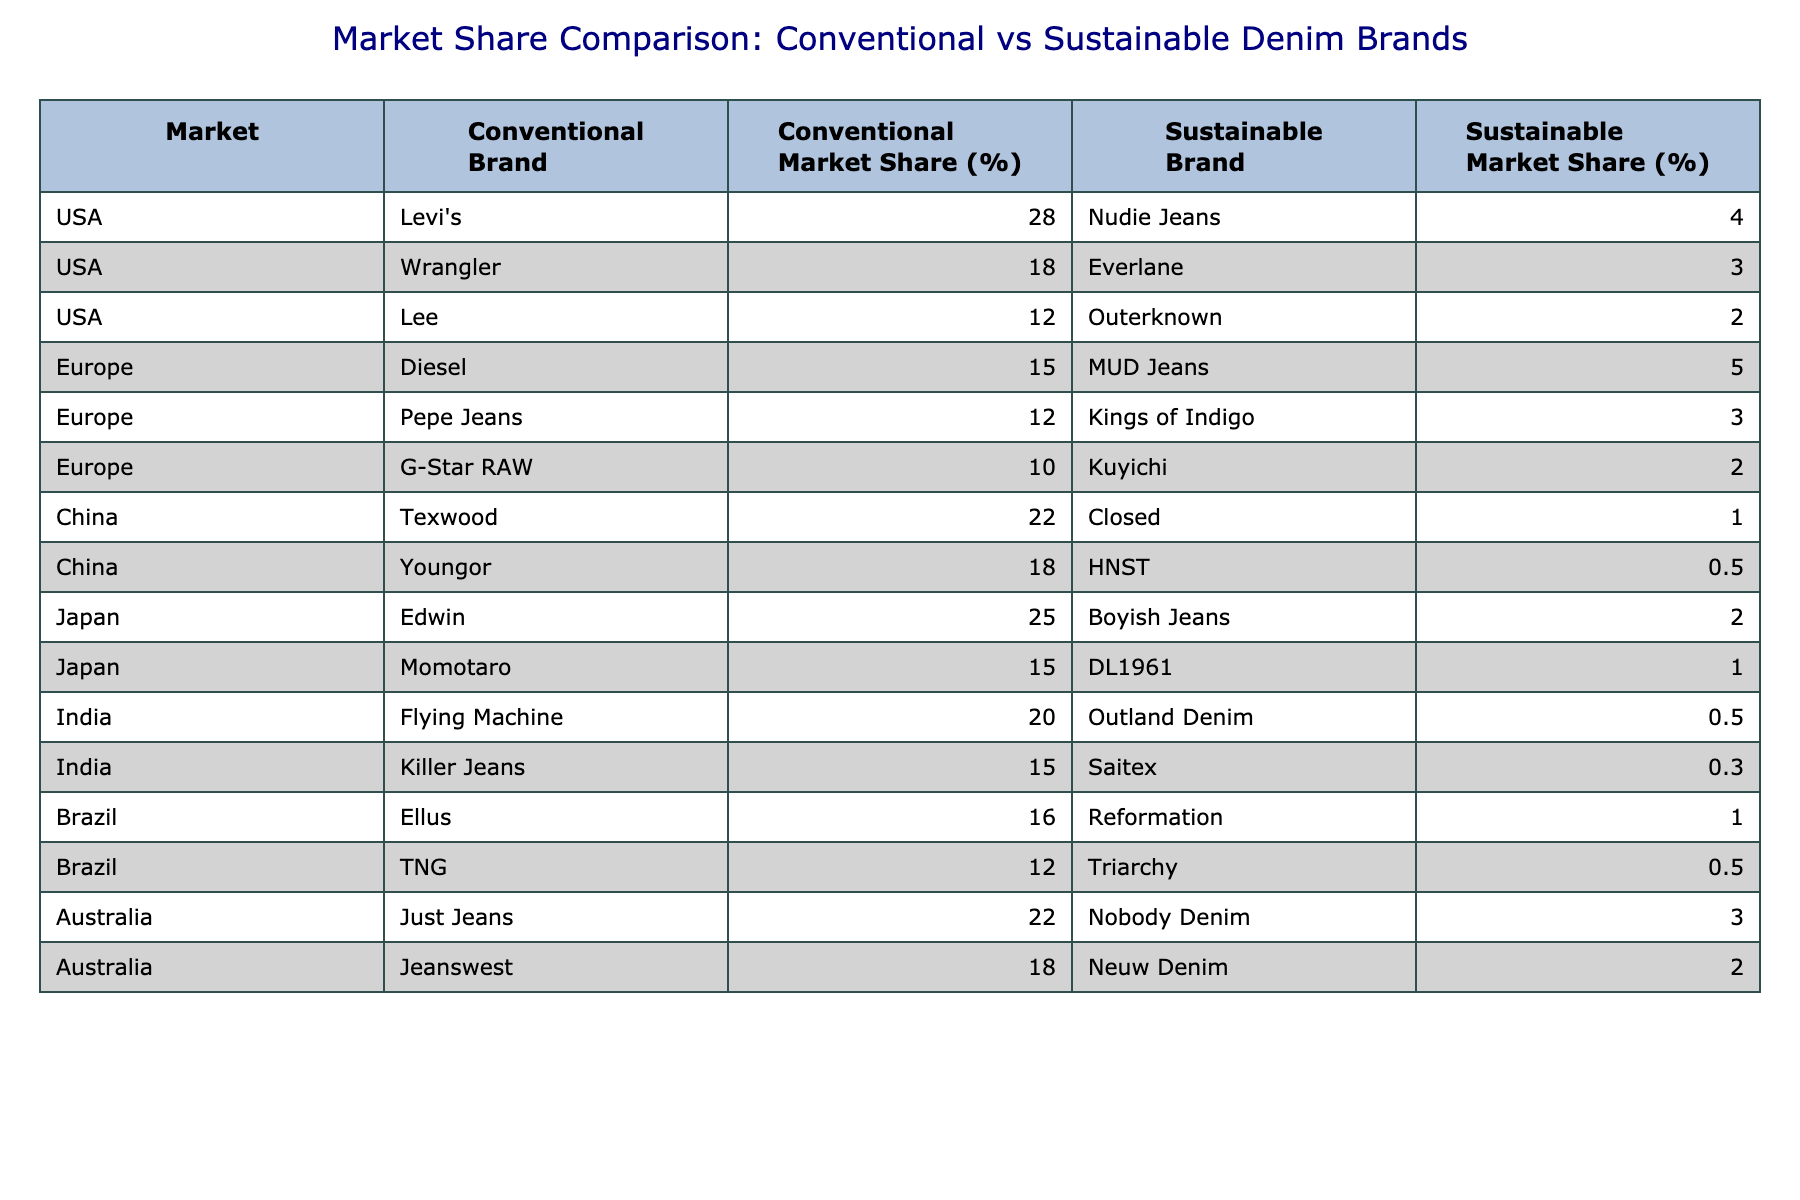What is the conventional market share of Levi's in the USA? The table lists Levi's under the USA market with a conventional market share of 28%.
Answer: 28% Which sustainable brand has the highest market share in the Europe region? In Europe, the sustainable brands are MUD Jeans (5%), Kings of Indigo (3%), and Kuyichi (2%). MUD Jeans has the highest market share at 5%.
Answer: MUD Jeans Is there a sustainable brand with a market share higher than 20% in any market? By examining the table, the highest sustainable market share is 5% (MUD Jeans in Europe), which is less than 20%. Thus, there is no sustainable brand with a market share over 20%.
Answer: No What is the difference in market share between the highest conventional brand (in USA) and the highest sustainable brand (in Europe)? The highest conventional brand in the USA is Levi's at 28%, and the highest sustainable brand in Europe is MUD Jeans at 5%. The difference is 28% - 5% = 23%.
Answer: 23% Are conventional brands generally more dominant in the market share compared to sustainable brands across all regions? The table shows that conventional brands have significantly higher market shares than sustainable brands in all regions listed, indicating a clear dominance of conventional brands.
Answer: Yes What is the average market share of sustainable brands in the USA? The sustainable brands in the USA are Nudie Jeans (4%), Everlane (3%), and Outerknown (2%). The average is calculated as (4 + 3 + 2) / 3 = 3%.
Answer: 3% Which market has the lowest total market share for sustainable brands? The sustainable brands in China have the lowest market share values. Closed has 1% and HNST has 0.5%, totaling 1.5%. This is lower than any other market’s sustainable shares.
Answer: China What percentage of the market share do conventional brands hold in Brazil? The table indicates that in Brazil, Ellus has 16% and TNG has 12%. The total conventional market share is 16% + 12% = 28%.
Answer: 28% 